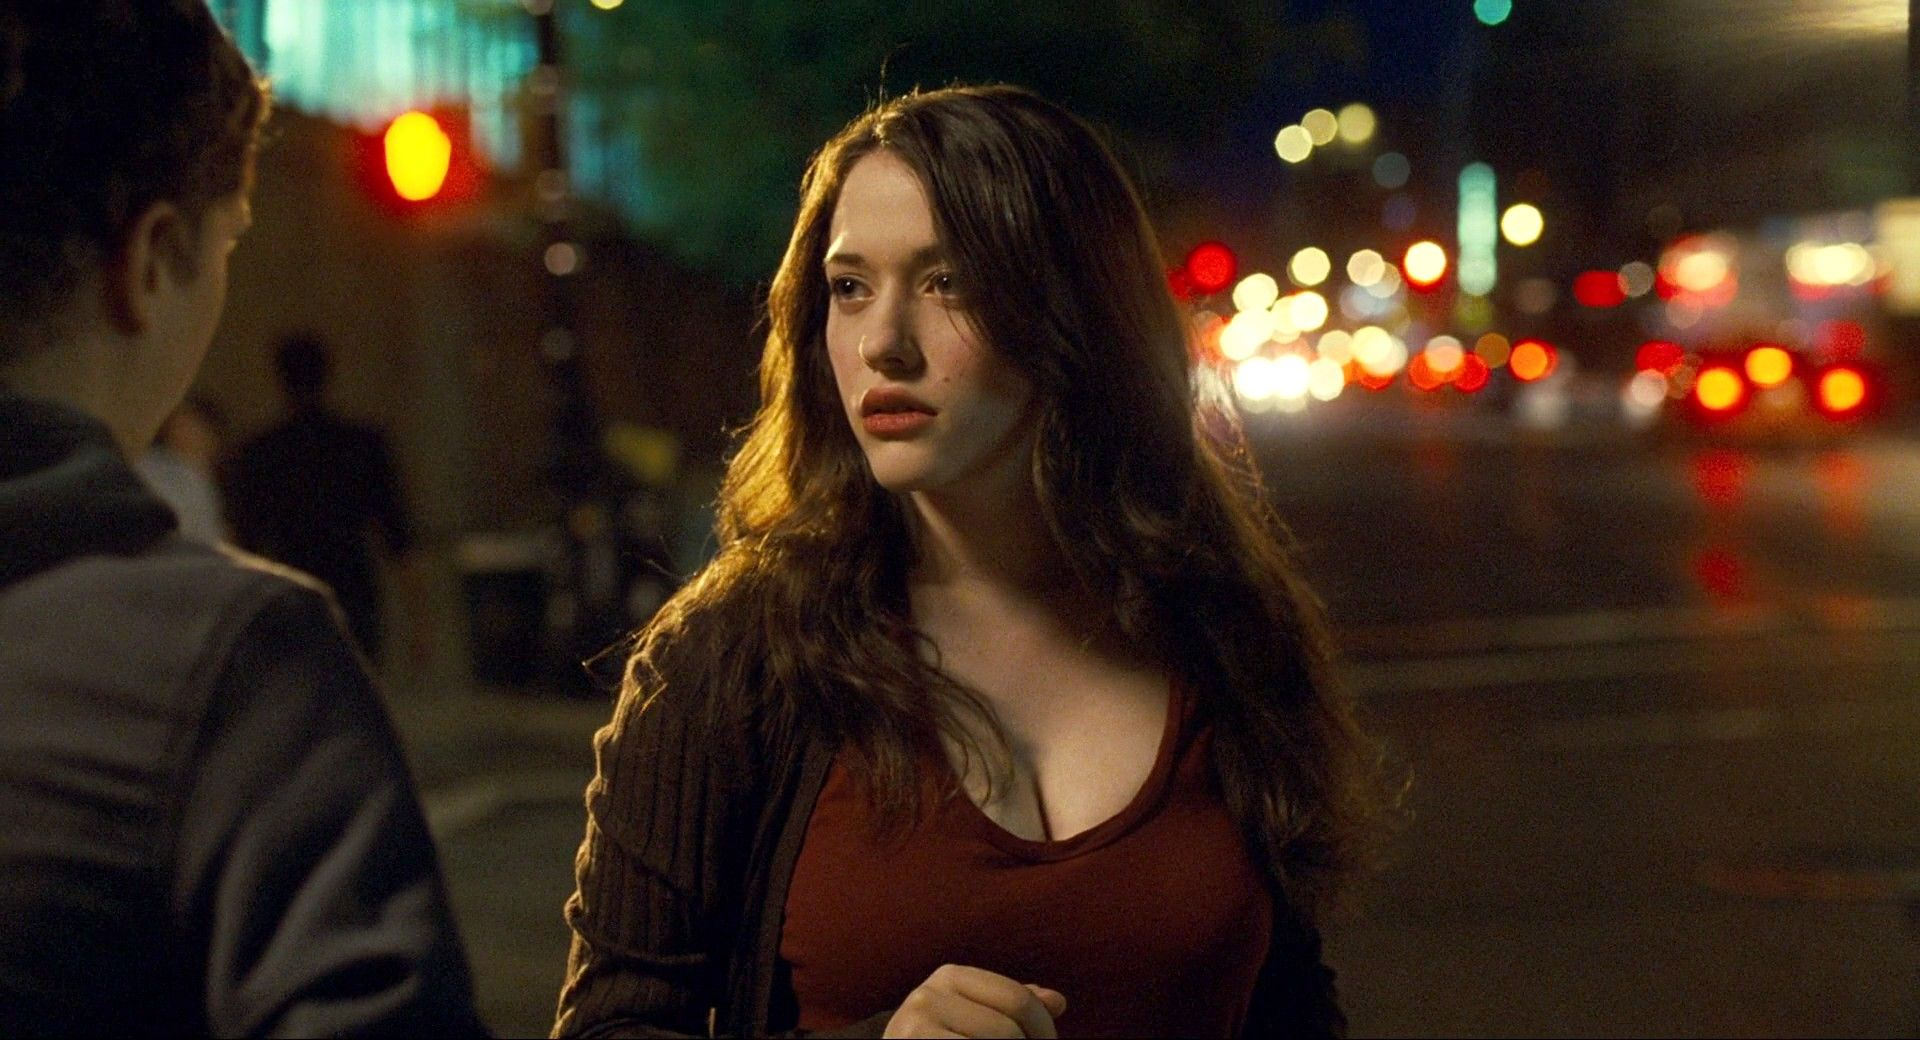If this image were the cover of a novel, what could be the title and the blurb? Title: 'City Lights, Silent Nights'
Blurb: In the heart of the city that never sleeps, one young woman finds herself at a crossroads, caught between her past and an uncertain future. Amidst the vibrant chaos of urban nights, her journey takes an unexpected turn when a ghost from her past reappears, forcing her to confront old memories and make life-altering decisions. 'City Lights, Silent Nights' is a tale of love, loss, and self-discovery set against the pulsating backdrop of city life. 